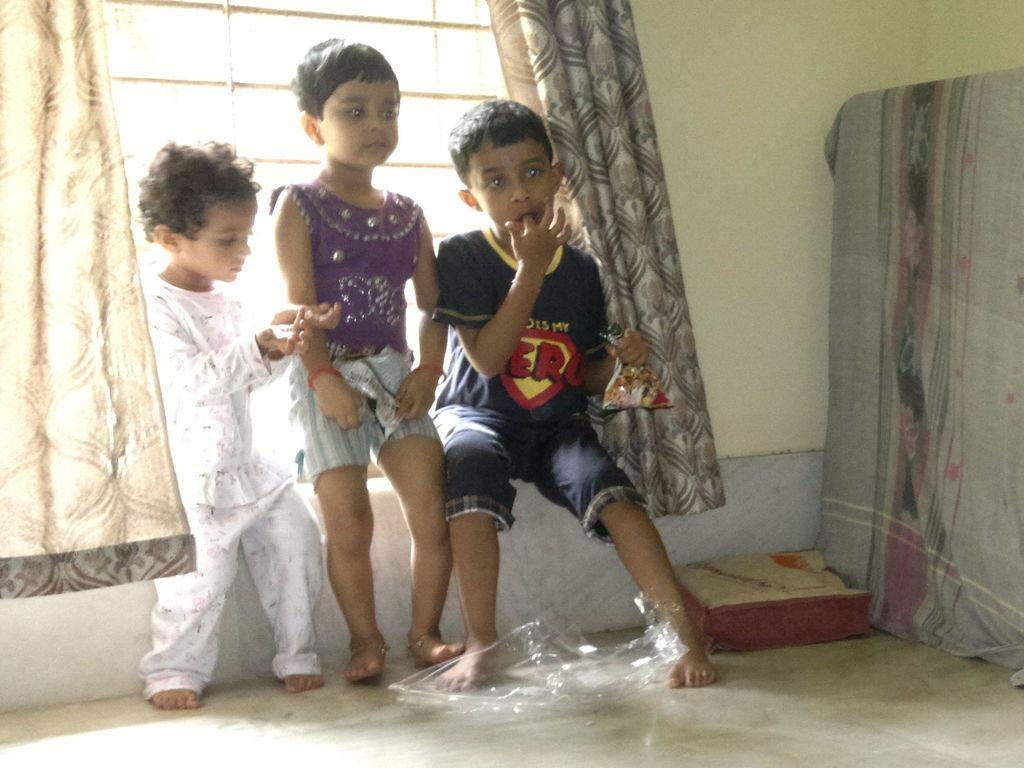How many kids are in the image? There are three kids in the image. Where are the kids located in the image? The kids are on the floor. What objects can be seen in the image besides the kids? There is a pillow, cloth, curtains, and a wall visible in the image. What architectural feature is present in the image? There is a window in the image. Can you describe the setting of the image? The image may have been taken in a hall. What type of blade is being used by the kids in the image? There is no blade present in the image; the kids are simply on the floor. Where did the kids go on vacation, as shown in the image? The image does not depict a vacation; it is a scene in a hall. 